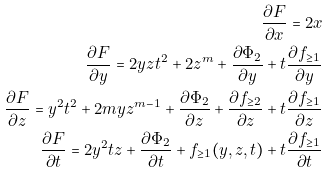Convert formula to latex. <formula><loc_0><loc_0><loc_500><loc_500>\frac { \partial F } { \partial x } = 2 x \\ \frac { \partial F } { \partial y } = 2 y z t ^ { 2 } + 2 z ^ { m } + \frac { \partial \Phi _ { 2 } } { \partial y } + t \frac { \partial f _ { \geq 1 } } { \partial y } \\ \frac { \partial F } { \partial z } = y ^ { 2 } t ^ { 2 } + 2 m y z ^ { m - 1 } + \frac { \partial \Phi _ { 2 } } { \partial z } + \frac { \partial f _ { \geq 2 } } { \partial z } + t \frac { \partial f _ { \geq 1 } } { \partial z } \\ \frac { \partial F } { \partial t } = 2 y ^ { 2 } t z + \frac { \partial \Phi _ { 2 } } { \partial t } + f _ { \geq 1 } ( y , z , t ) + t \frac { \partial f _ { \geq 1 } } { \partial t }</formula> 